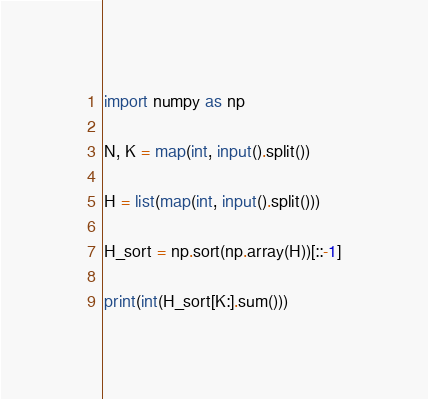Convert code to text. <code><loc_0><loc_0><loc_500><loc_500><_Python_>import numpy as np

N, K = map(int, input().split())

H = list(map(int, input().split()))

H_sort = np.sort(np.array(H))[::-1]

print(int(H_sort[K:].sum()))
</code> 